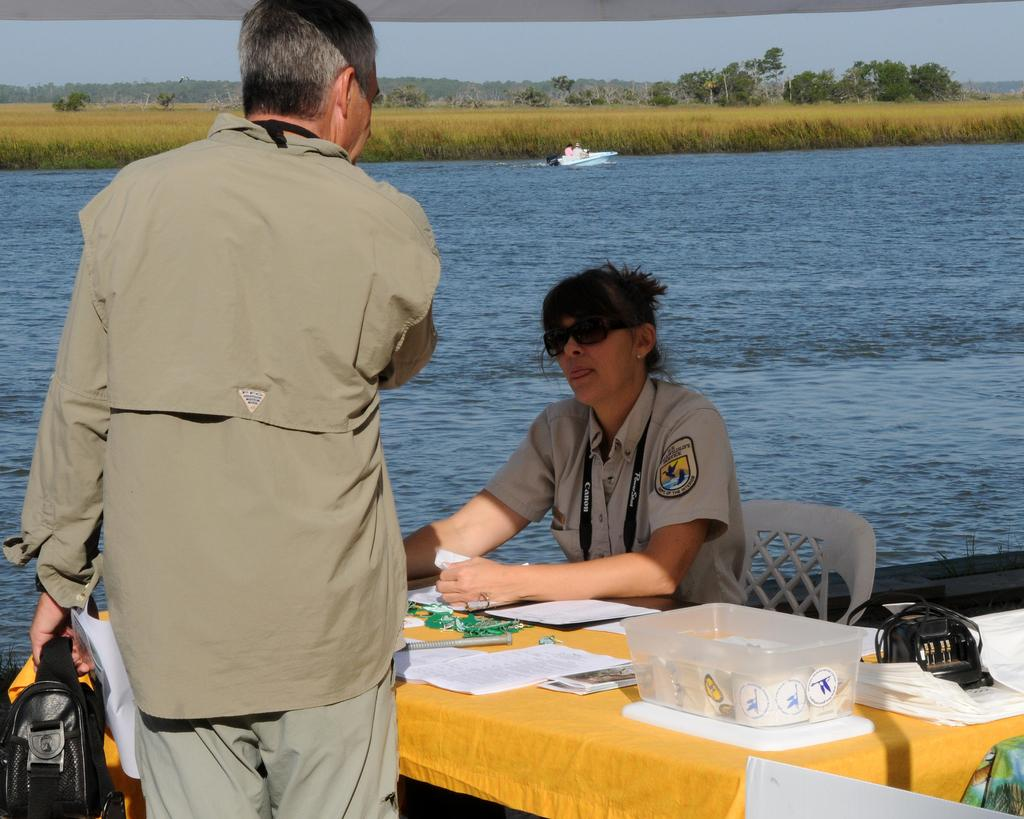What is the setting of the image? The image is taken in front of a lake. What is the position of the officer in the image? The officer is sitting on a chair in the image. What is the officer in front of? The officer is in front of a table in the image. What is on the table? The table has papers on it. What is the man in the image doing? There is a man standing in front of people in the image. What type of apparatus is being used by the officer in the image? There is no apparatus visible in the image; the officer is simply sitting on a chair and in front of a table. 